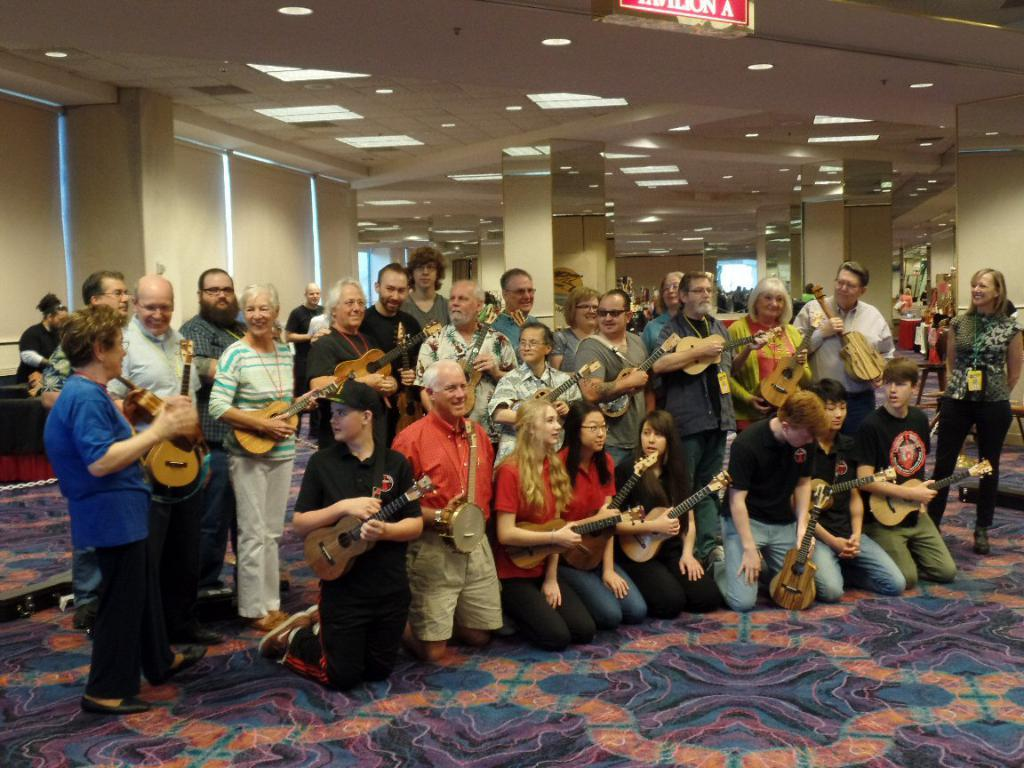What is happening in the image involving a group of people? The people are posing for a camera in the image. What are the people holding in their hands? The people are holding small guitars in their hands. What type of duck can be seen in the cemetery in the image? There is no duck or cemetery present in the image; it features a group of people posing with small guitars. 